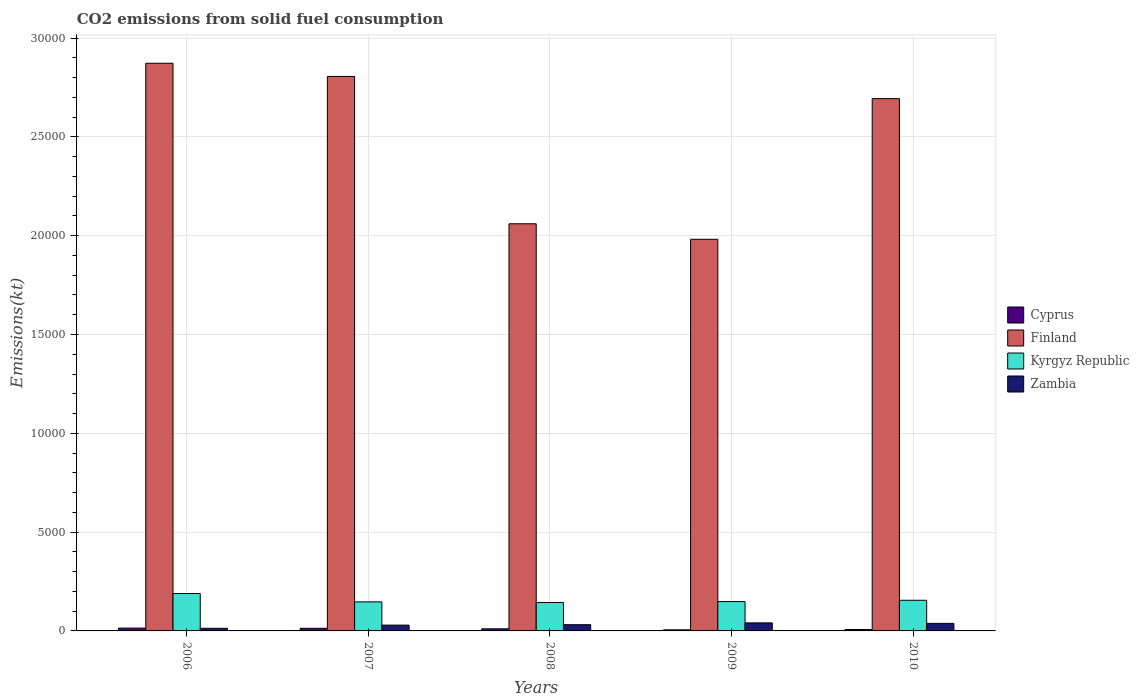How many different coloured bars are there?
Provide a succinct answer. 4. How many groups of bars are there?
Offer a very short reply. 5. How many bars are there on the 5th tick from the left?
Provide a short and direct response. 4. What is the label of the 4th group of bars from the left?
Your response must be concise. 2009. What is the amount of CO2 emitted in Finland in 2010?
Offer a terse response. 2.69e+04. Across all years, what is the maximum amount of CO2 emitted in Kyrgyz Republic?
Ensure brevity in your answer.  1892.17. Across all years, what is the minimum amount of CO2 emitted in Zambia?
Provide a short and direct response. 132.01. In which year was the amount of CO2 emitted in Zambia minimum?
Make the answer very short. 2006. What is the total amount of CO2 emitted in Finland in the graph?
Ensure brevity in your answer.  1.24e+05. What is the difference between the amount of CO2 emitted in Cyprus in 2006 and that in 2010?
Provide a short and direct response. 73.34. What is the difference between the amount of CO2 emitted in Finland in 2008 and the amount of CO2 emitted in Cyprus in 2009?
Give a very brief answer. 2.05e+04. What is the average amount of CO2 emitted in Kyrgyz Republic per year?
Ensure brevity in your answer.  1567.28. In the year 2010, what is the difference between the amount of CO2 emitted in Zambia and amount of CO2 emitted in Cyprus?
Provide a succinct answer. 311.7. In how many years, is the amount of CO2 emitted in Finland greater than 20000 kt?
Offer a very short reply. 4. What is the ratio of the amount of CO2 emitted in Finland in 2006 to that in 2007?
Offer a terse response. 1.02. Is the amount of CO2 emitted in Cyprus in 2009 less than that in 2010?
Offer a terse response. Yes. Is the difference between the amount of CO2 emitted in Zambia in 2009 and 2010 greater than the difference between the amount of CO2 emitted in Cyprus in 2009 and 2010?
Your answer should be compact. Yes. What is the difference between the highest and the second highest amount of CO2 emitted in Finland?
Provide a short and direct response. 667.39. What is the difference between the highest and the lowest amount of CO2 emitted in Kyrgyz Republic?
Offer a terse response. 454.71. In how many years, is the amount of CO2 emitted in Cyprus greater than the average amount of CO2 emitted in Cyprus taken over all years?
Give a very brief answer. 3. Is it the case that in every year, the sum of the amount of CO2 emitted in Finland and amount of CO2 emitted in Kyrgyz Republic is greater than the sum of amount of CO2 emitted in Zambia and amount of CO2 emitted in Cyprus?
Ensure brevity in your answer.  Yes. What does the 1st bar from the left in 2008 represents?
Your answer should be compact. Cyprus. What does the 1st bar from the right in 2009 represents?
Provide a short and direct response. Zambia. Is it the case that in every year, the sum of the amount of CO2 emitted in Cyprus and amount of CO2 emitted in Zambia is greater than the amount of CO2 emitted in Finland?
Provide a short and direct response. No. Are all the bars in the graph horizontal?
Offer a terse response. No. How many years are there in the graph?
Provide a succinct answer. 5. What is the difference between two consecutive major ticks on the Y-axis?
Offer a terse response. 5000. Does the graph contain grids?
Ensure brevity in your answer.  Yes. How are the legend labels stacked?
Your response must be concise. Vertical. What is the title of the graph?
Offer a very short reply. CO2 emissions from solid fuel consumption. Does "Afghanistan" appear as one of the legend labels in the graph?
Make the answer very short. No. What is the label or title of the Y-axis?
Your response must be concise. Emissions(kt). What is the Emissions(kt) in Cyprus in 2006?
Your answer should be very brief. 143.01. What is the Emissions(kt) of Finland in 2006?
Offer a terse response. 2.87e+04. What is the Emissions(kt) in Kyrgyz Republic in 2006?
Make the answer very short. 1892.17. What is the Emissions(kt) in Zambia in 2006?
Give a very brief answer. 132.01. What is the Emissions(kt) in Cyprus in 2007?
Your response must be concise. 132.01. What is the Emissions(kt) of Finland in 2007?
Ensure brevity in your answer.  2.81e+04. What is the Emissions(kt) in Kyrgyz Republic in 2007?
Your answer should be compact. 1470.47. What is the Emissions(kt) of Zambia in 2007?
Ensure brevity in your answer.  293.36. What is the Emissions(kt) of Cyprus in 2008?
Give a very brief answer. 106.34. What is the Emissions(kt) of Finland in 2008?
Your answer should be very brief. 2.06e+04. What is the Emissions(kt) in Kyrgyz Republic in 2008?
Your response must be concise. 1437.46. What is the Emissions(kt) of Zambia in 2008?
Offer a very short reply. 315.36. What is the Emissions(kt) of Cyprus in 2009?
Make the answer very short. 55.01. What is the Emissions(kt) of Finland in 2009?
Your answer should be compact. 1.98e+04. What is the Emissions(kt) of Kyrgyz Republic in 2009?
Your answer should be very brief. 1485.13. What is the Emissions(kt) of Zambia in 2009?
Provide a short and direct response. 407.04. What is the Emissions(kt) in Cyprus in 2010?
Keep it short and to the point. 69.67. What is the Emissions(kt) of Finland in 2010?
Your response must be concise. 2.69e+04. What is the Emissions(kt) in Kyrgyz Republic in 2010?
Give a very brief answer. 1551.14. What is the Emissions(kt) in Zambia in 2010?
Your answer should be compact. 381.37. Across all years, what is the maximum Emissions(kt) of Cyprus?
Keep it short and to the point. 143.01. Across all years, what is the maximum Emissions(kt) in Finland?
Your answer should be compact. 2.87e+04. Across all years, what is the maximum Emissions(kt) of Kyrgyz Republic?
Keep it short and to the point. 1892.17. Across all years, what is the maximum Emissions(kt) of Zambia?
Offer a terse response. 407.04. Across all years, what is the minimum Emissions(kt) in Cyprus?
Provide a short and direct response. 55.01. Across all years, what is the minimum Emissions(kt) of Finland?
Provide a short and direct response. 1.98e+04. Across all years, what is the minimum Emissions(kt) in Kyrgyz Republic?
Make the answer very short. 1437.46. Across all years, what is the minimum Emissions(kt) of Zambia?
Offer a terse response. 132.01. What is the total Emissions(kt) in Cyprus in the graph?
Ensure brevity in your answer.  506.05. What is the total Emissions(kt) of Finland in the graph?
Offer a terse response. 1.24e+05. What is the total Emissions(kt) of Kyrgyz Republic in the graph?
Your answer should be compact. 7836.38. What is the total Emissions(kt) of Zambia in the graph?
Give a very brief answer. 1529.14. What is the difference between the Emissions(kt) of Cyprus in 2006 and that in 2007?
Your answer should be compact. 11. What is the difference between the Emissions(kt) of Finland in 2006 and that in 2007?
Your answer should be very brief. 667.39. What is the difference between the Emissions(kt) of Kyrgyz Republic in 2006 and that in 2007?
Ensure brevity in your answer.  421.7. What is the difference between the Emissions(kt) in Zambia in 2006 and that in 2007?
Your response must be concise. -161.35. What is the difference between the Emissions(kt) in Cyprus in 2006 and that in 2008?
Ensure brevity in your answer.  36.67. What is the difference between the Emissions(kt) in Finland in 2006 and that in 2008?
Keep it short and to the point. 8122.4. What is the difference between the Emissions(kt) in Kyrgyz Republic in 2006 and that in 2008?
Ensure brevity in your answer.  454.71. What is the difference between the Emissions(kt) of Zambia in 2006 and that in 2008?
Ensure brevity in your answer.  -183.35. What is the difference between the Emissions(kt) of Cyprus in 2006 and that in 2009?
Your answer should be very brief. 88.01. What is the difference between the Emissions(kt) in Finland in 2006 and that in 2009?
Your response must be concise. 8907.14. What is the difference between the Emissions(kt) in Kyrgyz Republic in 2006 and that in 2009?
Keep it short and to the point. 407.04. What is the difference between the Emissions(kt) of Zambia in 2006 and that in 2009?
Give a very brief answer. -275.02. What is the difference between the Emissions(kt) in Cyprus in 2006 and that in 2010?
Provide a short and direct response. 73.34. What is the difference between the Emissions(kt) of Finland in 2006 and that in 2010?
Your answer should be compact. 1789.5. What is the difference between the Emissions(kt) in Kyrgyz Republic in 2006 and that in 2010?
Offer a very short reply. 341.03. What is the difference between the Emissions(kt) in Zambia in 2006 and that in 2010?
Provide a succinct answer. -249.36. What is the difference between the Emissions(kt) of Cyprus in 2007 and that in 2008?
Offer a terse response. 25.67. What is the difference between the Emissions(kt) of Finland in 2007 and that in 2008?
Provide a succinct answer. 7455.01. What is the difference between the Emissions(kt) of Kyrgyz Republic in 2007 and that in 2008?
Provide a succinct answer. 33. What is the difference between the Emissions(kt) in Zambia in 2007 and that in 2008?
Your answer should be compact. -22. What is the difference between the Emissions(kt) in Cyprus in 2007 and that in 2009?
Your answer should be compact. 77.01. What is the difference between the Emissions(kt) of Finland in 2007 and that in 2009?
Give a very brief answer. 8239.75. What is the difference between the Emissions(kt) of Kyrgyz Republic in 2007 and that in 2009?
Offer a terse response. -14.67. What is the difference between the Emissions(kt) in Zambia in 2007 and that in 2009?
Offer a very short reply. -113.68. What is the difference between the Emissions(kt) in Cyprus in 2007 and that in 2010?
Keep it short and to the point. 62.34. What is the difference between the Emissions(kt) in Finland in 2007 and that in 2010?
Offer a very short reply. 1122.1. What is the difference between the Emissions(kt) in Kyrgyz Republic in 2007 and that in 2010?
Provide a succinct answer. -80.67. What is the difference between the Emissions(kt) of Zambia in 2007 and that in 2010?
Offer a terse response. -88.01. What is the difference between the Emissions(kt) of Cyprus in 2008 and that in 2009?
Your response must be concise. 51.34. What is the difference between the Emissions(kt) of Finland in 2008 and that in 2009?
Offer a terse response. 784.74. What is the difference between the Emissions(kt) of Kyrgyz Republic in 2008 and that in 2009?
Your response must be concise. -47.67. What is the difference between the Emissions(kt) in Zambia in 2008 and that in 2009?
Your answer should be very brief. -91.67. What is the difference between the Emissions(kt) in Cyprus in 2008 and that in 2010?
Your answer should be compact. 36.67. What is the difference between the Emissions(kt) in Finland in 2008 and that in 2010?
Your response must be concise. -6332.91. What is the difference between the Emissions(kt) of Kyrgyz Republic in 2008 and that in 2010?
Your answer should be very brief. -113.68. What is the difference between the Emissions(kt) of Zambia in 2008 and that in 2010?
Keep it short and to the point. -66.01. What is the difference between the Emissions(kt) in Cyprus in 2009 and that in 2010?
Keep it short and to the point. -14.67. What is the difference between the Emissions(kt) of Finland in 2009 and that in 2010?
Your response must be concise. -7117.65. What is the difference between the Emissions(kt) of Kyrgyz Republic in 2009 and that in 2010?
Offer a very short reply. -66.01. What is the difference between the Emissions(kt) in Zambia in 2009 and that in 2010?
Ensure brevity in your answer.  25.67. What is the difference between the Emissions(kt) in Cyprus in 2006 and the Emissions(kt) in Finland in 2007?
Provide a succinct answer. -2.79e+04. What is the difference between the Emissions(kt) of Cyprus in 2006 and the Emissions(kt) of Kyrgyz Republic in 2007?
Ensure brevity in your answer.  -1327.45. What is the difference between the Emissions(kt) in Cyprus in 2006 and the Emissions(kt) in Zambia in 2007?
Keep it short and to the point. -150.35. What is the difference between the Emissions(kt) of Finland in 2006 and the Emissions(kt) of Kyrgyz Republic in 2007?
Your response must be concise. 2.73e+04. What is the difference between the Emissions(kt) in Finland in 2006 and the Emissions(kt) in Zambia in 2007?
Give a very brief answer. 2.84e+04. What is the difference between the Emissions(kt) of Kyrgyz Republic in 2006 and the Emissions(kt) of Zambia in 2007?
Offer a very short reply. 1598.81. What is the difference between the Emissions(kt) of Cyprus in 2006 and the Emissions(kt) of Finland in 2008?
Offer a terse response. -2.05e+04. What is the difference between the Emissions(kt) in Cyprus in 2006 and the Emissions(kt) in Kyrgyz Republic in 2008?
Make the answer very short. -1294.45. What is the difference between the Emissions(kt) in Cyprus in 2006 and the Emissions(kt) in Zambia in 2008?
Your answer should be compact. -172.35. What is the difference between the Emissions(kt) in Finland in 2006 and the Emissions(kt) in Kyrgyz Republic in 2008?
Offer a very short reply. 2.73e+04. What is the difference between the Emissions(kt) in Finland in 2006 and the Emissions(kt) in Zambia in 2008?
Make the answer very short. 2.84e+04. What is the difference between the Emissions(kt) in Kyrgyz Republic in 2006 and the Emissions(kt) in Zambia in 2008?
Offer a very short reply. 1576.81. What is the difference between the Emissions(kt) in Cyprus in 2006 and the Emissions(kt) in Finland in 2009?
Your answer should be very brief. -1.97e+04. What is the difference between the Emissions(kt) of Cyprus in 2006 and the Emissions(kt) of Kyrgyz Republic in 2009?
Ensure brevity in your answer.  -1342.12. What is the difference between the Emissions(kt) of Cyprus in 2006 and the Emissions(kt) of Zambia in 2009?
Make the answer very short. -264.02. What is the difference between the Emissions(kt) of Finland in 2006 and the Emissions(kt) of Kyrgyz Republic in 2009?
Offer a terse response. 2.72e+04. What is the difference between the Emissions(kt) in Finland in 2006 and the Emissions(kt) in Zambia in 2009?
Provide a succinct answer. 2.83e+04. What is the difference between the Emissions(kt) of Kyrgyz Republic in 2006 and the Emissions(kt) of Zambia in 2009?
Provide a short and direct response. 1485.13. What is the difference between the Emissions(kt) in Cyprus in 2006 and the Emissions(kt) in Finland in 2010?
Keep it short and to the point. -2.68e+04. What is the difference between the Emissions(kt) in Cyprus in 2006 and the Emissions(kt) in Kyrgyz Republic in 2010?
Provide a short and direct response. -1408.13. What is the difference between the Emissions(kt) in Cyprus in 2006 and the Emissions(kt) in Zambia in 2010?
Offer a very short reply. -238.35. What is the difference between the Emissions(kt) of Finland in 2006 and the Emissions(kt) of Kyrgyz Republic in 2010?
Ensure brevity in your answer.  2.72e+04. What is the difference between the Emissions(kt) of Finland in 2006 and the Emissions(kt) of Zambia in 2010?
Give a very brief answer. 2.83e+04. What is the difference between the Emissions(kt) in Kyrgyz Republic in 2006 and the Emissions(kt) in Zambia in 2010?
Keep it short and to the point. 1510.8. What is the difference between the Emissions(kt) in Cyprus in 2007 and the Emissions(kt) in Finland in 2008?
Offer a very short reply. -2.05e+04. What is the difference between the Emissions(kt) of Cyprus in 2007 and the Emissions(kt) of Kyrgyz Republic in 2008?
Your answer should be compact. -1305.45. What is the difference between the Emissions(kt) of Cyprus in 2007 and the Emissions(kt) of Zambia in 2008?
Give a very brief answer. -183.35. What is the difference between the Emissions(kt) of Finland in 2007 and the Emissions(kt) of Kyrgyz Republic in 2008?
Keep it short and to the point. 2.66e+04. What is the difference between the Emissions(kt) in Finland in 2007 and the Emissions(kt) in Zambia in 2008?
Your response must be concise. 2.77e+04. What is the difference between the Emissions(kt) in Kyrgyz Republic in 2007 and the Emissions(kt) in Zambia in 2008?
Provide a short and direct response. 1155.11. What is the difference between the Emissions(kt) in Cyprus in 2007 and the Emissions(kt) in Finland in 2009?
Your answer should be very brief. -1.97e+04. What is the difference between the Emissions(kt) of Cyprus in 2007 and the Emissions(kt) of Kyrgyz Republic in 2009?
Make the answer very short. -1353.12. What is the difference between the Emissions(kt) of Cyprus in 2007 and the Emissions(kt) of Zambia in 2009?
Provide a short and direct response. -275.02. What is the difference between the Emissions(kt) in Finland in 2007 and the Emissions(kt) in Kyrgyz Republic in 2009?
Keep it short and to the point. 2.66e+04. What is the difference between the Emissions(kt) in Finland in 2007 and the Emissions(kt) in Zambia in 2009?
Your response must be concise. 2.76e+04. What is the difference between the Emissions(kt) in Kyrgyz Republic in 2007 and the Emissions(kt) in Zambia in 2009?
Provide a succinct answer. 1063.43. What is the difference between the Emissions(kt) of Cyprus in 2007 and the Emissions(kt) of Finland in 2010?
Give a very brief answer. -2.68e+04. What is the difference between the Emissions(kt) of Cyprus in 2007 and the Emissions(kt) of Kyrgyz Republic in 2010?
Offer a very short reply. -1419.13. What is the difference between the Emissions(kt) of Cyprus in 2007 and the Emissions(kt) of Zambia in 2010?
Provide a succinct answer. -249.36. What is the difference between the Emissions(kt) of Finland in 2007 and the Emissions(kt) of Kyrgyz Republic in 2010?
Provide a short and direct response. 2.65e+04. What is the difference between the Emissions(kt) of Finland in 2007 and the Emissions(kt) of Zambia in 2010?
Offer a very short reply. 2.77e+04. What is the difference between the Emissions(kt) in Kyrgyz Republic in 2007 and the Emissions(kt) in Zambia in 2010?
Offer a terse response. 1089.1. What is the difference between the Emissions(kt) of Cyprus in 2008 and the Emissions(kt) of Finland in 2009?
Give a very brief answer. -1.97e+04. What is the difference between the Emissions(kt) of Cyprus in 2008 and the Emissions(kt) of Kyrgyz Republic in 2009?
Make the answer very short. -1378.79. What is the difference between the Emissions(kt) in Cyprus in 2008 and the Emissions(kt) in Zambia in 2009?
Make the answer very short. -300.69. What is the difference between the Emissions(kt) of Finland in 2008 and the Emissions(kt) of Kyrgyz Republic in 2009?
Offer a terse response. 1.91e+04. What is the difference between the Emissions(kt) in Finland in 2008 and the Emissions(kt) in Zambia in 2009?
Offer a very short reply. 2.02e+04. What is the difference between the Emissions(kt) in Kyrgyz Republic in 2008 and the Emissions(kt) in Zambia in 2009?
Give a very brief answer. 1030.43. What is the difference between the Emissions(kt) of Cyprus in 2008 and the Emissions(kt) of Finland in 2010?
Make the answer very short. -2.68e+04. What is the difference between the Emissions(kt) in Cyprus in 2008 and the Emissions(kt) in Kyrgyz Republic in 2010?
Provide a short and direct response. -1444.8. What is the difference between the Emissions(kt) of Cyprus in 2008 and the Emissions(kt) of Zambia in 2010?
Provide a short and direct response. -275.02. What is the difference between the Emissions(kt) in Finland in 2008 and the Emissions(kt) in Kyrgyz Republic in 2010?
Offer a terse response. 1.91e+04. What is the difference between the Emissions(kt) of Finland in 2008 and the Emissions(kt) of Zambia in 2010?
Provide a short and direct response. 2.02e+04. What is the difference between the Emissions(kt) of Kyrgyz Republic in 2008 and the Emissions(kt) of Zambia in 2010?
Your response must be concise. 1056.1. What is the difference between the Emissions(kt) of Cyprus in 2009 and the Emissions(kt) of Finland in 2010?
Your answer should be very brief. -2.69e+04. What is the difference between the Emissions(kt) of Cyprus in 2009 and the Emissions(kt) of Kyrgyz Republic in 2010?
Your answer should be very brief. -1496.14. What is the difference between the Emissions(kt) in Cyprus in 2009 and the Emissions(kt) in Zambia in 2010?
Your response must be concise. -326.36. What is the difference between the Emissions(kt) in Finland in 2009 and the Emissions(kt) in Kyrgyz Republic in 2010?
Keep it short and to the point. 1.83e+04. What is the difference between the Emissions(kt) of Finland in 2009 and the Emissions(kt) of Zambia in 2010?
Ensure brevity in your answer.  1.94e+04. What is the difference between the Emissions(kt) of Kyrgyz Republic in 2009 and the Emissions(kt) of Zambia in 2010?
Ensure brevity in your answer.  1103.77. What is the average Emissions(kt) of Cyprus per year?
Your answer should be very brief. 101.21. What is the average Emissions(kt) in Finland per year?
Your answer should be compact. 2.48e+04. What is the average Emissions(kt) in Kyrgyz Republic per year?
Make the answer very short. 1567.28. What is the average Emissions(kt) in Zambia per year?
Keep it short and to the point. 305.83. In the year 2006, what is the difference between the Emissions(kt) in Cyprus and Emissions(kt) in Finland?
Your answer should be very brief. -2.86e+04. In the year 2006, what is the difference between the Emissions(kt) of Cyprus and Emissions(kt) of Kyrgyz Republic?
Provide a succinct answer. -1749.16. In the year 2006, what is the difference between the Emissions(kt) of Cyprus and Emissions(kt) of Zambia?
Give a very brief answer. 11. In the year 2006, what is the difference between the Emissions(kt) of Finland and Emissions(kt) of Kyrgyz Republic?
Your answer should be very brief. 2.68e+04. In the year 2006, what is the difference between the Emissions(kt) of Finland and Emissions(kt) of Zambia?
Ensure brevity in your answer.  2.86e+04. In the year 2006, what is the difference between the Emissions(kt) of Kyrgyz Republic and Emissions(kt) of Zambia?
Make the answer very short. 1760.16. In the year 2007, what is the difference between the Emissions(kt) in Cyprus and Emissions(kt) in Finland?
Keep it short and to the point. -2.79e+04. In the year 2007, what is the difference between the Emissions(kt) in Cyprus and Emissions(kt) in Kyrgyz Republic?
Provide a short and direct response. -1338.45. In the year 2007, what is the difference between the Emissions(kt) of Cyprus and Emissions(kt) of Zambia?
Provide a succinct answer. -161.35. In the year 2007, what is the difference between the Emissions(kt) of Finland and Emissions(kt) of Kyrgyz Republic?
Offer a very short reply. 2.66e+04. In the year 2007, what is the difference between the Emissions(kt) of Finland and Emissions(kt) of Zambia?
Give a very brief answer. 2.78e+04. In the year 2007, what is the difference between the Emissions(kt) in Kyrgyz Republic and Emissions(kt) in Zambia?
Offer a terse response. 1177.11. In the year 2008, what is the difference between the Emissions(kt) in Cyprus and Emissions(kt) in Finland?
Make the answer very short. -2.05e+04. In the year 2008, what is the difference between the Emissions(kt) in Cyprus and Emissions(kt) in Kyrgyz Republic?
Make the answer very short. -1331.12. In the year 2008, what is the difference between the Emissions(kt) of Cyprus and Emissions(kt) of Zambia?
Provide a succinct answer. -209.02. In the year 2008, what is the difference between the Emissions(kt) in Finland and Emissions(kt) in Kyrgyz Republic?
Provide a succinct answer. 1.92e+04. In the year 2008, what is the difference between the Emissions(kt) in Finland and Emissions(kt) in Zambia?
Ensure brevity in your answer.  2.03e+04. In the year 2008, what is the difference between the Emissions(kt) of Kyrgyz Republic and Emissions(kt) of Zambia?
Give a very brief answer. 1122.1. In the year 2009, what is the difference between the Emissions(kt) of Cyprus and Emissions(kt) of Finland?
Provide a succinct answer. -1.98e+04. In the year 2009, what is the difference between the Emissions(kt) of Cyprus and Emissions(kt) of Kyrgyz Republic?
Make the answer very short. -1430.13. In the year 2009, what is the difference between the Emissions(kt) of Cyprus and Emissions(kt) of Zambia?
Keep it short and to the point. -352.03. In the year 2009, what is the difference between the Emissions(kt) of Finland and Emissions(kt) of Kyrgyz Republic?
Provide a succinct answer. 1.83e+04. In the year 2009, what is the difference between the Emissions(kt) in Finland and Emissions(kt) in Zambia?
Offer a very short reply. 1.94e+04. In the year 2009, what is the difference between the Emissions(kt) of Kyrgyz Republic and Emissions(kt) of Zambia?
Provide a short and direct response. 1078.1. In the year 2010, what is the difference between the Emissions(kt) of Cyprus and Emissions(kt) of Finland?
Ensure brevity in your answer.  -2.69e+04. In the year 2010, what is the difference between the Emissions(kt) of Cyprus and Emissions(kt) of Kyrgyz Republic?
Provide a short and direct response. -1481.47. In the year 2010, what is the difference between the Emissions(kt) of Cyprus and Emissions(kt) of Zambia?
Your answer should be compact. -311.69. In the year 2010, what is the difference between the Emissions(kt) in Finland and Emissions(kt) in Kyrgyz Republic?
Keep it short and to the point. 2.54e+04. In the year 2010, what is the difference between the Emissions(kt) in Finland and Emissions(kt) in Zambia?
Your response must be concise. 2.66e+04. In the year 2010, what is the difference between the Emissions(kt) in Kyrgyz Republic and Emissions(kt) in Zambia?
Ensure brevity in your answer.  1169.77. What is the ratio of the Emissions(kt) in Finland in 2006 to that in 2007?
Ensure brevity in your answer.  1.02. What is the ratio of the Emissions(kt) of Kyrgyz Republic in 2006 to that in 2007?
Your answer should be compact. 1.29. What is the ratio of the Emissions(kt) in Zambia in 2006 to that in 2007?
Provide a short and direct response. 0.45. What is the ratio of the Emissions(kt) in Cyprus in 2006 to that in 2008?
Offer a terse response. 1.34. What is the ratio of the Emissions(kt) of Finland in 2006 to that in 2008?
Offer a terse response. 1.39. What is the ratio of the Emissions(kt) in Kyrgyz Republic in 2006 to that in 2008?
Keep it short and to the point. 1.32. What is the ratio of the Emissions(kt) of Zambia in 2006 to that in 2008?
Provide a short and direct response. 0.42. What is the ratio of the Emissions(kt) of Finland in 2006 to that in 2009?
Offer a terse response. 1.45. What is the ratio of the Emissions(kt) in Kyrgyz Republic in 2006 to that in 2009?
Your answer should be very brief. 1.27. What is the ratio of the Emissions(kt) of Zambia in 2006 to that in 2009?
Offer a very short reply. 0.32. What is the ratio of the Emissions(kt) in Cyprus in 2006 to that in 2010?
Offer a terse response. 2.05. What is the ratio of the Emissions(kt) in Finland in 2006 to that in 2010?
Offer a terse response. 1.07. What is the ratio of the Emissions(kt) of Kyrgyz Republic in 2006 to that in 2010?
Provide a short and direct response. 1.22. What is the ratio of the Emissions(kt) of Zambia in 2006 to that in 2010?
Give a very brief answer. 0.35. What is the ratio of the Emissions(kt) in Cyprus in 2007 to that in 2008?
Give a very brief answer. 1.24. What is the ratio of the Emissions(kt) of Finland in 2007 to that in 2008?
Provide a short and direct response. 1.36. What is the ratio of the Emissions(kt) of Zambia in 2007 to that in 2008?
Provide a short and direct response. 0.93. What is the ratio of the Emissions(kt) in Cyprus in 2007 to that in 2009?
Offer a very short reply. 2.4. What is the ratio of the Emissions(kt) of Finland in 2007 to that in 2009?
Your answer should be compact. 1.42. What is the ratio of the Emissions(kt) of Kyrgyz Republic in 2007 to that in 2009?
Offer a very short reply. 0.99. What is the ratio of the Emissions(kt) of Zambia in 2007 to that in 2009?
Make the answer very short. 0.72. What is the ratio of the Emissions(kt) in Cyprus in 2007 to that in 2010?
Make the answer very short. 1.89. What is the ratio of the Emissions(kt) in Finland in 2007 to that in 2010?
Ensure brevity in your answer.  1.04. What is the ratio of the Emissions(kt) in Kyrgyz Republic in 2007 to that in 2010?
Give a very brief answer. 0.95. What is the ratio of the Emissions(kt) in Zambia in 2007 to that in 2010?
Give a very brief answer. 0.77. What is the ratio of the Emissions(kt) in Cyprus in 2008 to that in 2009?
Offer a terse response. 1.93. What is the ratio of the Emissions(kt) of Finland in 2008 to that in 2009?
Your answer should be very brief. 1.04. What is the ratio of the Emissions(kt) of Kyrgyz Republic in 2008 to that in 2009?
Ensure brevity in your answer.  0.97. What is the ratio of the Emissions(kt) in Zambia in 2008 to that in 2009?
Provide a succinct answer. 0.77. What is the ratio of the Emissions(kt) in Cyprus in 2008 to that in 2010?
Your response must be concise. 1.53. What is the ratio of the Emissions(kt) of Finland in 2008 to that in 2010?
Your response must be concise. 0.76. What is the ratio of the Emissions(kt) in Kyrgyz Republic in 2008 to that in 2010?
Give a very brief answer. 0.93. What is the ratio of the Emissions(kt) in Zambia in 2008 to that in 2010?
Your answer should be compact. 0.83. What is the ratio of the Emissions(kt) of Cyprus in 2009 to that in 2010?
Give a very brief answer. 0.79. What is the ratio of the Emissions(kt) in Finland in 2009 to that in 2010?
Ensure brevity in your answer.  0.74. What is the ratio of the Emissions(kt) of Kyrgyz Republic in 2009 to that in 2010?
Offer a terse response. 0.96. What is the ratio of the Emissions(kt) in Zambia in 2009 to that in 2010?
Offer a very short reply. 1.07. What is the difference between the highest and the second highest Emissions(kt) of Cyprus?
Provide a succinct answer. 11. What is the difference between the highest and the second highest Emissions(kt) in Finland?
Offer a terse response. 667.39. What is the difference between the highest and the second highest Emissions(kt) of Kyrgyz Republic?
Provide a succinct answer. 341.03. What is the difference between the highest and the second highest Emissions(kt) in Zambia?
Offer a terse response. 25.67. What is the difference between the highest and the lowest Emissions(kt) of Cyprus?
Your answer should be compact. 88.01. What is the difference between the highest and the lowest Emissions(kt) of Finland?
Offer a very short reply. 8907.14. What is the difference between the highest and the lowest Emissions(kt) in Kyrgyz Republic?
Give a very brief answer. 454.71. What is the difference between the highest and the lowest Emissions(kt) of Zambia?
Your answer should be compact. 275.02. 